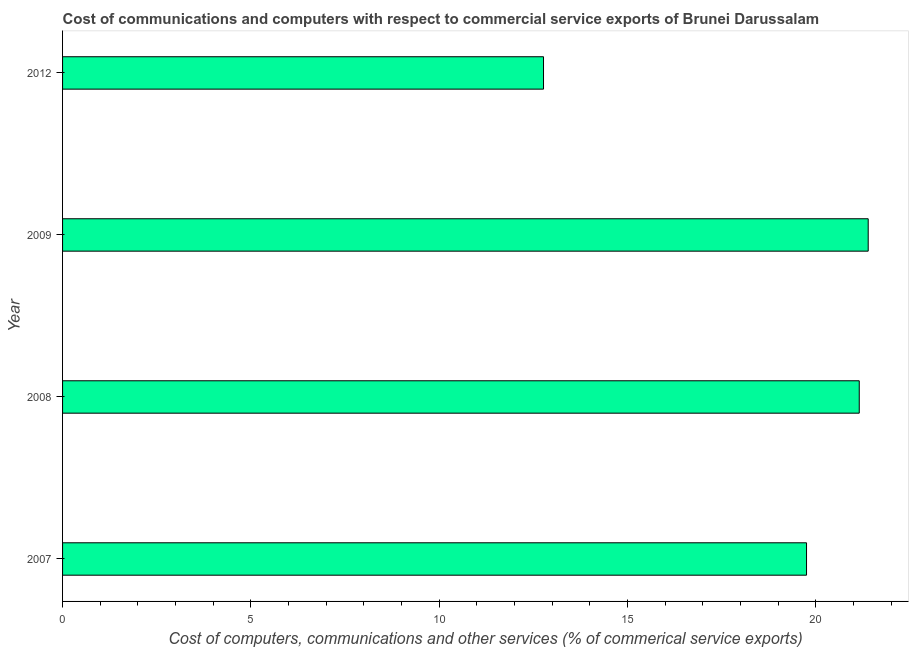Does the graph contain grids?
Keep it short and to the point. No. What is the title of the graph?
Keep it short and to the point. Cost of communications and computers with respect to commercial service exports of Brunei Darussalam. What is the label or title of the X-axis?
Keep it short and to the point. Cost of computers, communications and other services (% of commerical service exports). What is the label or title of the Y-axis?
Provide a short and direct response. Year. What is the cost of communications in 2007?
Make the answer very short. 19.75. Across all years, what is the maximum  computer and other services?
Your answer should be compact. 21.39. Across all years, what is the minimum  computer and other services?
Offer a very short reply. 12.77. In which year was the  computer and other services minimum?
Your answer should be compact. 2012. What is the sum of the  computer and other services?
Ensure brevity in your answer.  75.07. What is the difference between the cost of communications in 2007 and 2009?
Your answer should be very brief. -1.64. What is the average cost of communications per year?
Your answer should be very brief. 18.77. What is the median  computer and other services?
Offer a terse response. 20.45. What is the ratio of the cost of communications in 2007 to that in 2008?
Provide a short and direct response. 0.93. Is the difference between the  computer and other services in 2007 and 2012 greater than the difference between any two years?
Give a very brief answer. No. What is the difference between the highest and the second highest  computer and other services?
Give a very brief answer. 0.24. Is the sum of the  computer and other services in 2007 and 2012 greater than the maximum  computer and other services across all years?
Keep it short and to the point. Yes. What is the difference between the highest and the lowest  computer and other services?
Make the answer very short. 8.62. How many bars are there?
Your answer should be compact. 4. What is the difference between two consecutive major ticks on the X-axis?
Make the answer very short. 5. What is the Cost of computers, communications and other services (% of commerical service exports) in 2007?
Provide a succinct answer. 19.75. What is the Cost of computers, communications and other services (% of commerical service exports) of 2008?
Your answer should be compact. 21.15. What is the Cost of computers, communications and other services (% of commerical service exports) of 2009?
Provide a succinct answer. 21.39. What is the Cost of computers, communications and other services (% of commerical service exports) of 2012?
Offer a very short reply. 12.77. What is the difference between the Cost of computers, communications and other services (% of commerical service exports) in 2007 and 2008?
Your answer should be compact. -1.4. What is the difference between the Cost of computers, communications and other services (% of commerical service exports) in 2007 and 2009?
Ensure brevity in your answer.  -1.64. What is the difference between the Cost of computers, communications and other services (% of commerical service exports) in 2007 and 2012?
Your answer should be compact. 6.98. What is the difference between the Cost of computers, communications and other services (% of commerical service exports) in 2008 and 2009?
Your answer should be compact. -0.24. What is the difference between the Cost of computers, communications and other services (% of commerical service exports) in 2008 and 2012?
Offer a terse response. 8.38. What is the difference between the Cost of computers, communications and other services (% of commerical service exports) in 2009 and 2012?
Make the answer very short. 8.62. What is the ratio of the Cost of computers, communications and other services (% of commerical service exports) in 2007 to that in 2008?
Keep it short and to the point. 0.93. What is the ratio of the Cost of computers, communications and other services (% of commerical service exports) in 2007 to that in 2009?
Provide a succinct answer. 0.92. What is the ratio of the Cost of computers, communications and other services (% of commerical service exports) in 2007 to that in 2012?
Make the answer very short. 1.55. What is the ratio of the Cost of computers, communications and other services (% of commerical service exports) in 2008 to that in 2009?
Give a very brief answer. 0.99. What is the ratio of the Cost of computers, communications and other services (% of commerical service exports) in 2008 to that in 2012?
Provide a short and direct response. 1.66. What is the ratio of the Cost of computers, communications and other services (% of commerical service exports) in 2009 to that in 2012?
Your answer should be compact. 1.68. 